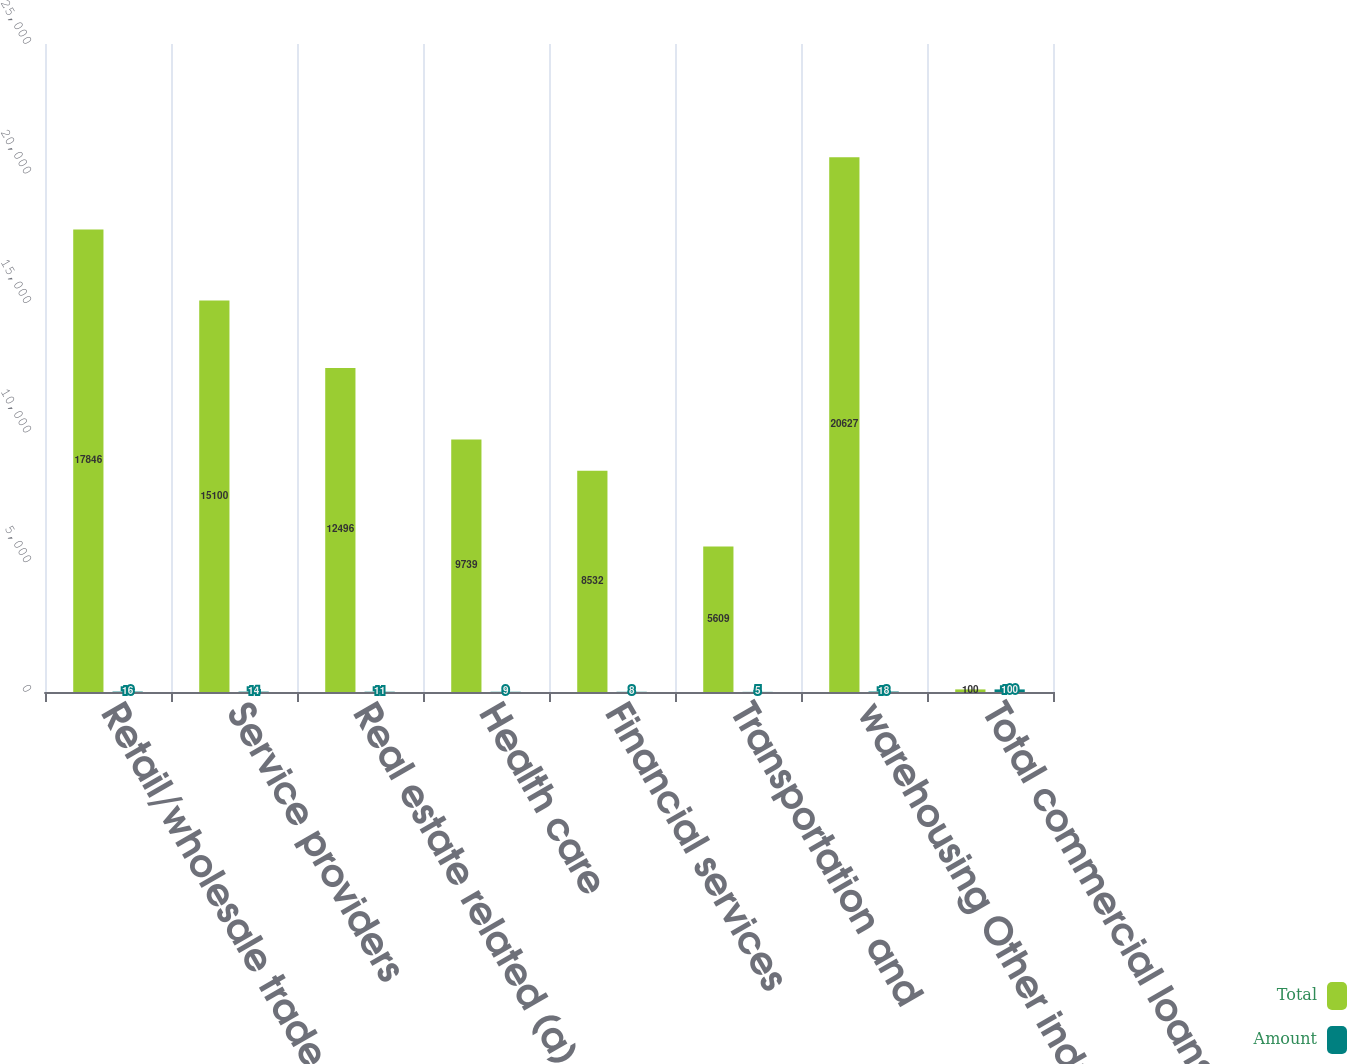<chart> <loc_0><loc_0><loc_500><loc_500><stacked_bar_chart><ecel><fcel>Retail/wholesale trade<fcel>Service providers<fcel>Real estate related (a)<fcel>Health care<fcel>Financial services<fcel>Transportation and<fcel>warehousing Other industries<fcel>Total commercial loans<nl><fcel>Total<fcel>17846<fcel>15100<fcel>12496<fcel>9739<fcel>8532<fcel>5609<fcel>20627<fcel>100<nl><fcel>Amount<fcel>16<fcel>14<fcel>11<fcel>9<fcel>8<fcel>5<fcel>18<fcel>100<nl></chart> 